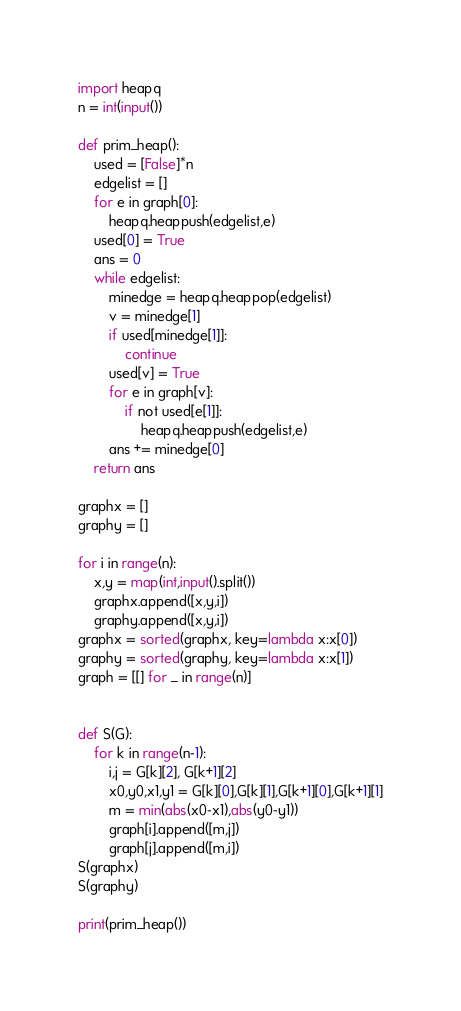Convert code to text. <code><loc_0><loc_0><loc_500><loc_500><_Python_>import heapq
n = int(input())

def prim_heap():
    used = [False]*n
    edgelist = []
    for e in graph[0]:
        heapq.heappush(edgelist,e)
    used[0] = True
    ans = 0
    while edgelist:
        minedge = heapq.heappop(edgelist)
        v = minedge[1]
        if used[minedge[1]]:
            continue
        used[v] = True
        for e in graph[v]:
            if not used[e[1]]:
                heapq.heappush(edgelist,e)
        ans += minedge[0]
    return ans

graphx = []
graphy = []

for i in range(n):
    x,y = map(int,input().split())
    graphx.append([x,y,i])
    graphy.append([x,y,i])
graphx = sorted(graphx, key=lambda x:x[0])
graphy = sorted(graphy, key=lambda x:x[1])
graph = [[] for _ in range(n)]


def S(G):
    for k in range(n-1):
        i,j = G[k][2], G[k+1][2]
        x0,y0,x1,y1 = G[k][0],G[k][1],G[k+1][0],G[k+1][1]
        m = min(abs(x0-x1),abs(y0-y1))
        graph[i].append([m,j])
        graph[j].append([m,i])
S(graphx)
S(graphy)

print(prim_heap())</code> 